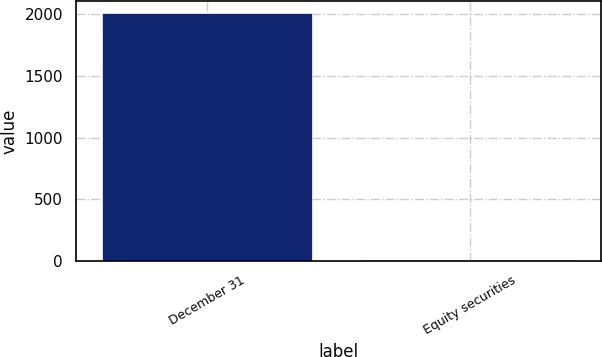Convert chart to OTSL. <chart><loc_0><loc_0><loc_500><loc_500><bar_chart><fcel>December 31<fcel>Equity securities<nl><fcel>2008<fcel>4<nl></chart> 